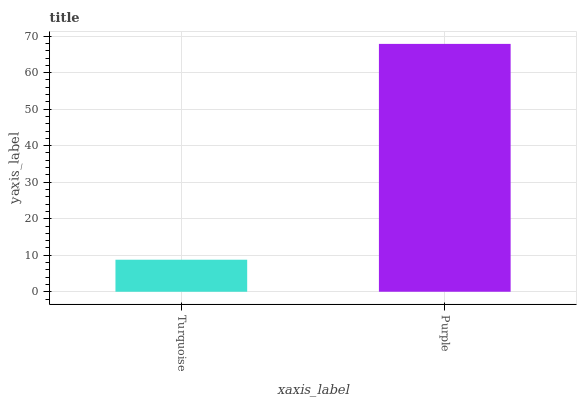Is Turquoise the minimum?
Answer yes or no. Yes. Is Purple the maximum?
Answer yes or no. Yes. Is Purple the minimum?
Answer yes or no. No. Is Purple greater than Turquoise?
Answer yes or no. Yes. Is Turquoise less than Purple?
Answer yes or no. Yes. Is Turquoise greater than Purple?
Answer yes or no. No. Is Purple less than Turquoise?
Answer yes or no. No. Is Purple the high median?
Answer yes or no. Yes. Is Turquoise the low median?
Answer yes or no. Yes. Is Turquoise the high median?
Answer yes or no. No. Is Purple the low median?
Answer yes or no. No. 